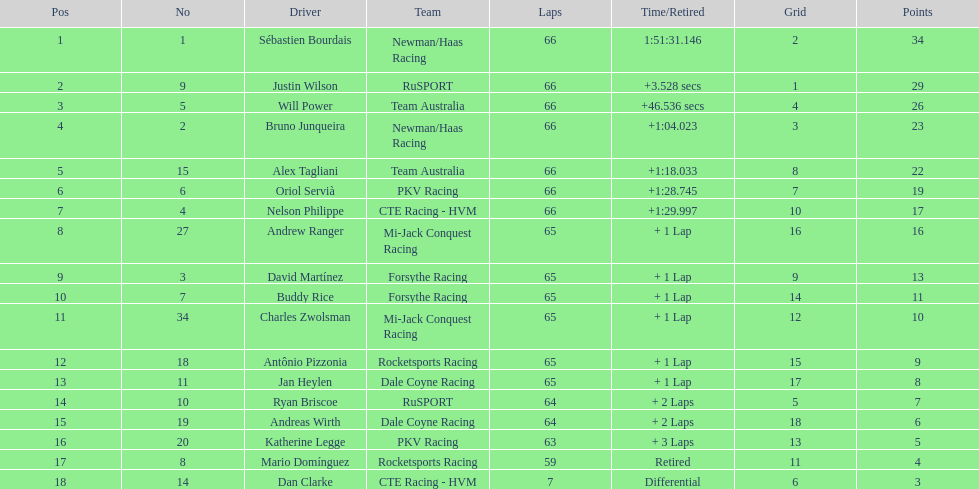Between oriol servia and katherine legge, who managed to complete more laps at the 2006 gran premio telmex? Oriol Servià. 